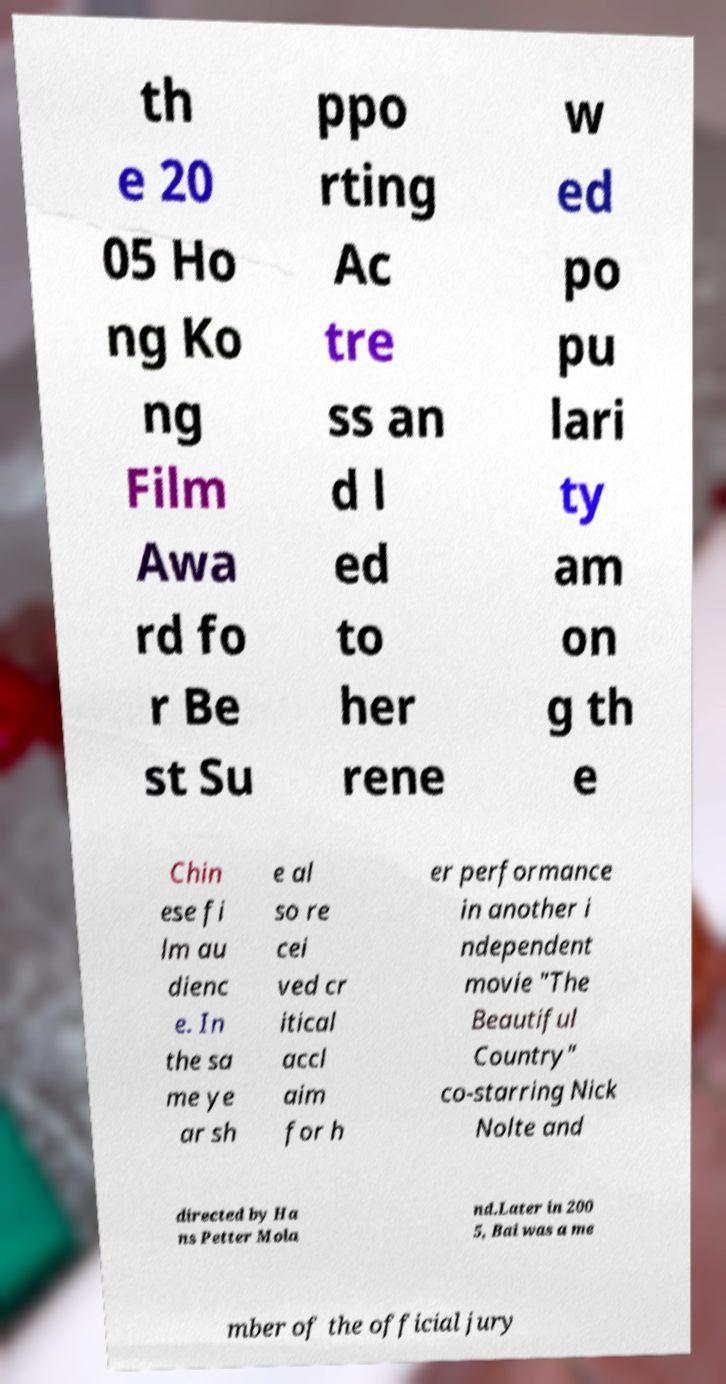I need the written content from this picture converted into text. Can you do that? th e 20 05 Ho ng Ko ng Film Awa rd fo r Be st Su ppo rting Ac tre ss an d l ed to her rene w ed po pu lari ty am on g th e Chin ese fi lm au dienc e. In the sa me ye ar sh e al so re cei ved cr itical accl aim for h er performance in another i ndependent movie "The Beautiful Country" co-starring Nick Nolte and directed by Ha ns Petter Mola nd.Later in 200 5, Bai was a me mber of the official jury 